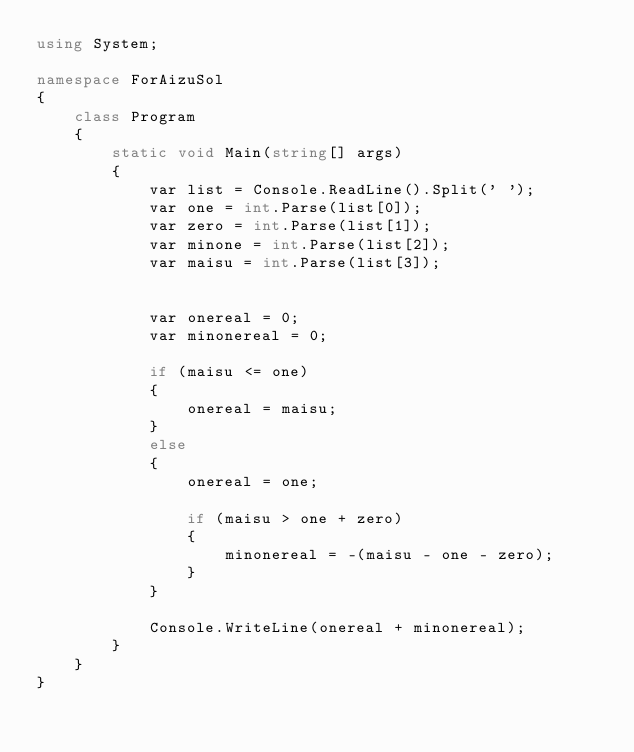Convert code to text. <code><loc_0><loc_0><loc_500><loc_500><_C#_>using System;

namespace ForAizuSol
{
    class Program
    {
        static void Main(string[] args)
        {
            var list = Console.ReadLine().Split(' ');
            var one = int.Parse(list[0]);
            var zero = int.Parse(list[1]);
            var minone = int.Parse(list[2]);
            var maisu = int.Parse(list[3]);


            var onereal = 0;
            var minonereal = 0;

            if (maisu <= one)
            {
                onereal = maisu;
            }
            else
            {
                onereal = one;

                if (maisu > one + zero)
                {
                    minonereal = -(maisu - one - zero);
                }
            }

            Console.WriteLine(onereal + minonereal);
        }
    }
}</code> 